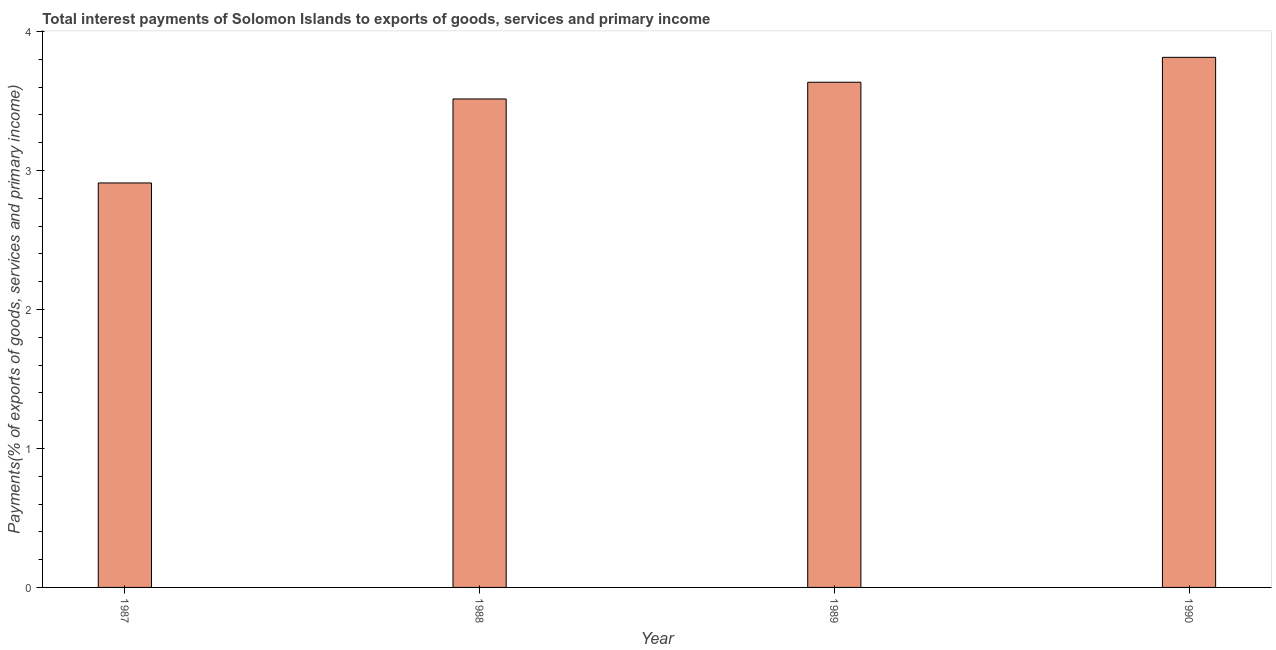What is the title of the graph?
Give a very brief answer. Total interest payments of Solomon Islands to exports of goods, services and primary income. What is the label or title of the X-axis?
Ensure brevity in your answer.  Year. What is the label or title of the Y-axis?
Keep it short and to the point. Payments(% of exports of goods, services and primary income). What is the total interest payments on external debt in 1990?
Your response must be concise. 3.81. Across all years, what is the maximum total interest payments on external debt?
Offer a very short reply. 3.81. Across all years, what is the minimum total interest payments on external debt?
Offer a very short reply. 2.91. What is the sum of the total interest payments on external debt?
Offer a very short reply. 13.87. What is the difference between the total interest payments on external debt in 1987 and 1988?
Offer a very short reply. -0.6. What is the average total interest payments on external debt per year?
Provide a succinct answer. 3.47. What is the median total interest payments on external debt?
Make the answer very short. 3.57. Do a majority of the years between 1987 and 1988 (inclusive) have total interest payments on external debt greater than 3 %?
Offer a terse response. No. Is the total interest payments on external debt in 1987 less than that in 1988?
Your answer should be very brief. Yes. What is the difference between the highest and the second highest total interest payments on external debt?
Offer a terse response. 0.18. What is the difference between the highest and the lowest total interest payments on external debt?
Your answer should be very brief. 0.9. In how many years, is the total interest payments on external debt greater than the average total interest payments on external debt taken over all years?
Your answer should be very brief. 3. How many bars are there?
Give a very brief answer. 4. What is the Payments(% of exports of goods, services and primary income) in 1987?
Your answer should be very brief. 2.91. What is the Payments(% of exports of goods, services and primary income) of 1988?
Offer a terse response. 3.51. What is the Payments(% of exports of goods, services and primary income) in 1989?
Give a very brief answer. 3.63. What is the Payments(% of exports of goods, services and primary income) of 1990?
Make the answer very short. 3.81. What is the difference between the Payments(% of exports of goods, services and primary income) in 1987 and 1988?
Make the answer very short. -0.6. What is the difference between the Payments(% of exports of goods, services and primary income) in 1987 and 1989?
Offer a very short reply. -0.72. What is the difference between the Payments(% of exports of goods, services and primary income) in 1987 and 1990?
Your answer should be compact. -0.9. What is the difference between the Payments(% of exports of goods, services and primary income) in 1988 and 1989?
Keep it short and to the point. -0.12. What is the difference between the Payments(% of exports of goods, services and primary income) in 1988 and 1990?
Offer a terse response. -0.3. What is the difference between the Payments(% of exports of goods, services and primary income) in 1989 and 1990?
Provide a succinct answer. -0.18. What is the ratio of the Payments(% of exports of goods, services and primary income) in 1987 to that in 1988?
Offer a terse response. 0.83. What is the ratio of the Payments(% of exports of goods, services and primary income) in 1987 to that in 1989?
Provide a short and direct response. 0.8. What is the ratio of the Payments(% of exports of goods, services and primary income) in 1987 to that in 1990?
Offer a terse response. 0.76. What is the ratio of the Payments(% of exports of goods, services and primary income) in 1988 to that in 1990?
Provide a short and direct response. 0.92. What is the ratio of the Payments(% of exports of goods, services and primary income) in 1989 to that in 1990?
Keep it short and to the point. 0.95. 